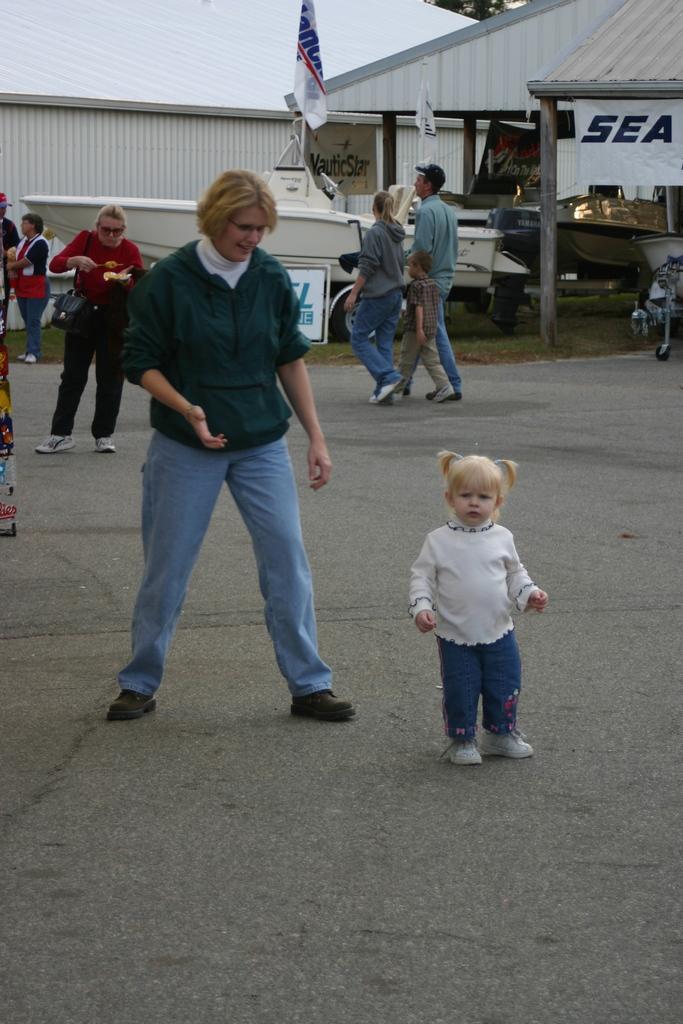Could you give a brief overview of what you see in this image? In this image we can see many people. In the back there is a flag. Also there is a building with pillars. 